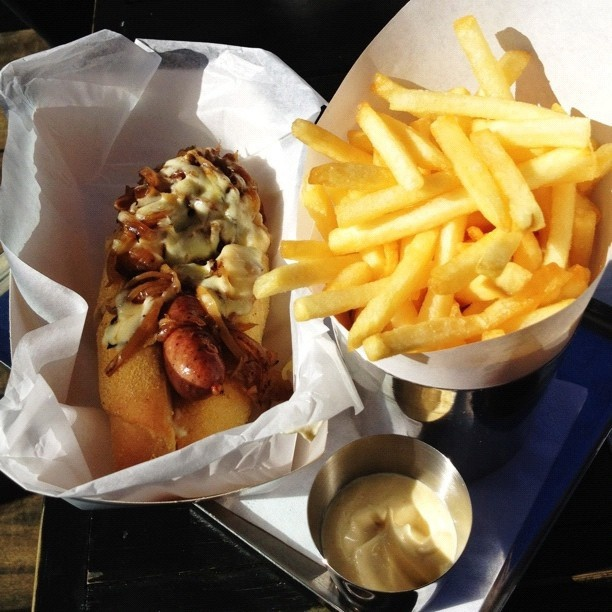Describe the objects in this image and their specific colors. I can see dining table in black, ivory, maroon, orange, and darkgray tones, hot dog in black, maroon, and brown tones, cup in black, maroon, and olive tones, bowl in black, maroon, and olive tones, and bowl in black, gray, and darkgray tones in this image. 